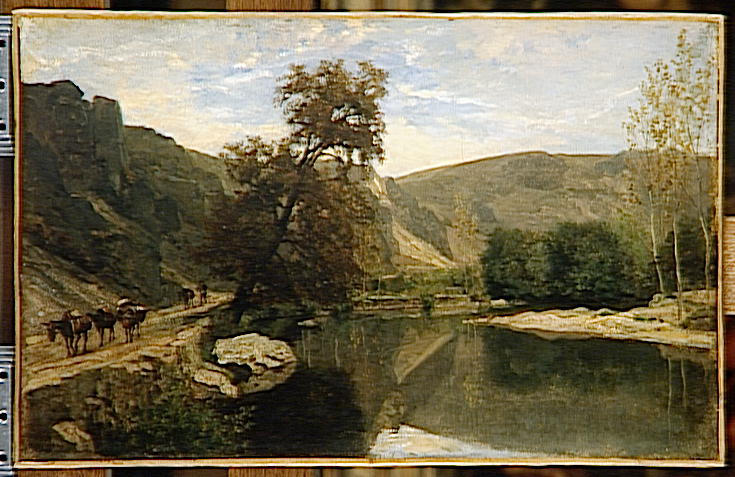Can you elaborate on the elements of the picture provided? This painting showcases the serene beauty of the countryside with a tranquil and picturesque landscape. The style is impressionist, evident through the use of loose brushstrokes that capture the overall essence rather than intricate details. The color palette is dominated by earthy tones, mainly greens, browns, and blues, contributing to the painting's calming effect.

The scene features a gently flowing river or stream that winds its way through a lush valley. Several cows are visible as they cross the water, bringing an element of life to the tranquil setting. The background is dotted with verdant trees and softly undulating hills, further enhancing the idyllic rural atmosphere.

Above, a pale blue sky stretches across the horizon, lightly decorated with wispy, delicate clouds that add depth and dimension to the scene. This harmonious depiction encapsulates the peaceful coexistence of nature and animals, a common theme in landscape art. The artist’s adept use of color and form creates a sense of perspective and depth, drawing viewers into the scenic vista. The result is a beautiful and timeless portrayal of a serene moment in the countryside, captured vividly on canvas. 